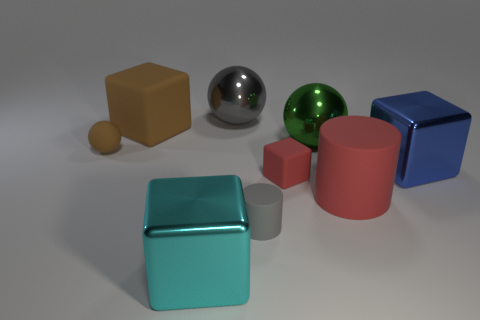Subtract 1 cubes. How many cubes are left? 3 Add 1 brown objects. How many objects exist? 10 Subtract all cubes. How many objects are left? 5 Subtract all gray balls. Subtract all green rubber objects. How many objects are left? 8 Add 9 big blue metal objects. How many big blue metal objects are left? 10 Add 6 brown matte things. How many brown matte things exist? 8 Subtract 1 cyan cubes. How many objects are left? 8 